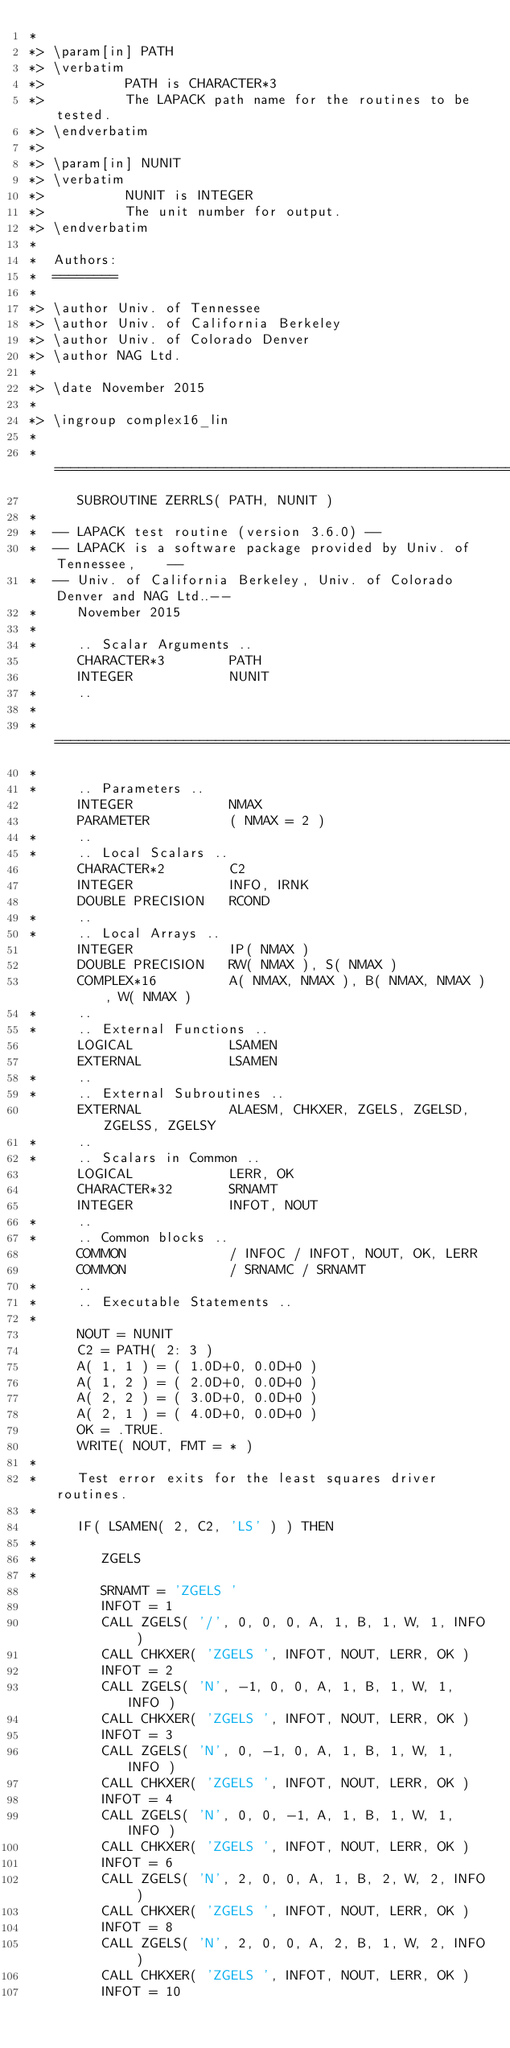<code> <loc_0><loc_0><loc_500><loc_500><_FORTRAN_>*
*> \param[in] PATH
*> \verbatim
*>          PATH is CHARACTER*3
*>          The LAPACK path name for the routines to be tested.
*> \endverbatim
*>
*> \param[in] NUNIT
*> \verbatim
*>          NUNIT is INTEGER
*>          The unit number for output.
*> \endverbatim
*
*  Authors:
*  ========
*
*> \author Univ. of Tennessee 
*> \author Univ. of California Berkeley 
*> \author Univ. of Colorado Denver 
*> \author NAG Ltd. 
*
*> \date November 2015
*
*> \ingroup complex16_lin
*
*  =====================================================================
      SUBROUTINE ZERRLS( PATH, NUNIT )
*
*  -- LAPACK test routine (version 3.6.0) --
*  -- LAPACK is a software package provided by Univ. of Tennessee,    --
*  -- Univ. of California Berkeley, Univ. of Colorado Denver and NAG Ltd..--
*     November 2015
*
*     .. Scalar Arguments ..
      CHARACTER*3        PATH
      INTEGER            NUNIT
*     ..
*
*  =====================================================================
*
*     .. Parameters ..
      INTEGER            NMAX
      PARAMETER          ( NMAX = 2 )
*     ..
*     .. Local Scalars ..
      CHARACTER*2        C2
      INTEGER            INFO, IRNK
      DOUBLE PRECISION   RCOND
*     ..
*     .. Local Arrays ..
      INTEGER            IP( NMAX )
      DOUBLE PRECISION   RW( NMAX ), S( NMAX )
      COMPLEX*16         A( NMAX, NMAX ), B( NMAX, NMAX ), W( NMAX )
*     ..
*     .. External Functions ..
      LOGICAL            LSAMEN
      EXTERNAL           LSAMEN
*     ..
*     .. External Subroutines ..
      EXTERNAL           ALAESM, CHKXER, ZGELS, ZGELSD, ZGELSS, ZGELSY
*     ..
*     .. Scalars in Common ..
      LOGICAL            LERR, OK
      CHARACTER*32       SRNAMT
      INTEGER            INFOT, NOUT
*     ..
*     .. Common blocks ..
      COMMON             / INFOC / INFOT, NOUT, OK, LERR
      COMMON             / SRNAMC / SRNAMT
*     ..
*     .. Executable Statements ..
*
      NOUT = NUNIT
      C2 = PATH( 2: 3 )
      A( 1, 1 ) = ( 1.0D+0, 0.0D+0 )
      A( 1, 2 ) = ( 2.0D+0, 0.0D+0 )
      A( 2, 2 ) = ( 3.0D+0, 0.0D+0 )
      A( 2, 1 ) = ( 4.0D+0, 0.0D+0 )
      OK = .TRUE.
      WRITE( NOUT, FMT = * )
*
*     Test error exits for the least squares driver routines.
*
      IF( LSAMEN( 2, C2, 'LS' ) ) THEN
*
*        ZGELS
*
         SRNAMT = 'ZGELS '
         INFOT = 1
         CALL ZGELS( '/', 0, 0, 0, A, 1, B, 1, W, 1, INFO )
         CALL CHKXER( 'ZGELS ', INFOT, NOUT, LERR, OK )
         INFOT = 2
         CALL ZGELS( 'N', -1, 0, 0, A, 1, B, 1, W, 1, INFO )
         CALL CHKXER( 'ZGELS ', INFOT, NOUT, LERR, OK )
         INFOT = 3
         CALL ZGELS( 'N', 0, -1, 0, A, 1, B, 1, W, 1, INFO )
         CALL CHKXER( 'ZGELS ', INFOT, NOUT, LERR, OK )
         INFOT = 4
         CALL ZGELS( 'N', 0, 0, -1, A, 1, B, 1, W, 1, INFO )
         CALL CHKXER( 'ZGELS ', INFOT, NOUT, LERR, OK )
         INFOT = 6
         CALL ZGELS( 'N', 2, 0, 0, A, 1, B, 2, W, 2, INFO )
         CALL CHKXER( 'ZGELS ', INFOT, NOUT, LERR, OK )
         INFOT = 8
         CALL ZGELS( 'N', 2, 0, 0, A, 2, B, 1, W, 2, INFO )
         CALL CHKXER( 'ZGELS ', INFOT, NOUT, LERR, OK )
         INFOT = 10</code> 